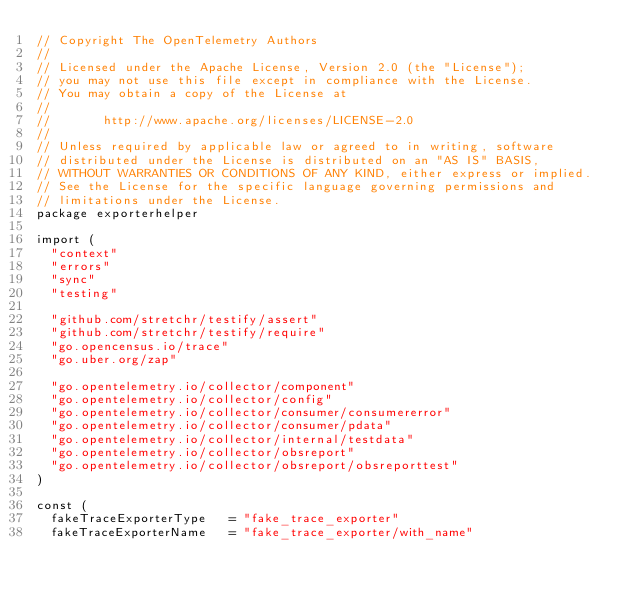Convert code to text. <code><loc_0><loc_0><loc_500><loc_500><_Go_>// Copyright The OpenTelemetry Authors
//
// Licensed under the Apache License, Version 2.0 (the "License");
// you may not use this file except in compliance with the License.
// You may obtain a copy of the License at
//
//       http://www.apache.org/licenses/LICENSE-2.0
//
// Unless required by applicable law or agreed to in writing, software
// distributed under the License is distributed on an "AS IS" BASIS,
// WITHOUT WARRANTIES OR CONDITIONS OF ANY KIND, either express or implied.
// See the License for the specific language governing permissions and
// limitations under the License.
package exporterhelper

import (
	"context"
	"errors"
	"sync"
	"testing"

	"github.com/stretchr/testify/assert"
	"github.com/stretchr/testify/require"
	"go.opencensus.io/trace"
	"go.uber.org/zap"

	"go.opentelemetry.io/collector/component"
	"go.opentelemetry.io/collector/config"
	"go.opentelemetry.io/collector/consumer/consumererror"
	"go.opentelemetry.io/collector/consumer/pdata"
	"go.opentelemetry.io/collector/internal/testdata"
	"go.opentelemetry.io/collector/obsreport"
	"go.opentelemetry.io/collector/obsreport/obsreporttest"
)

const (
	fakeTraceExporterType   = "fake_trace_exporter"
	fakeTraceExporterName   = "fake_trace_exporter/with_name"</code> 